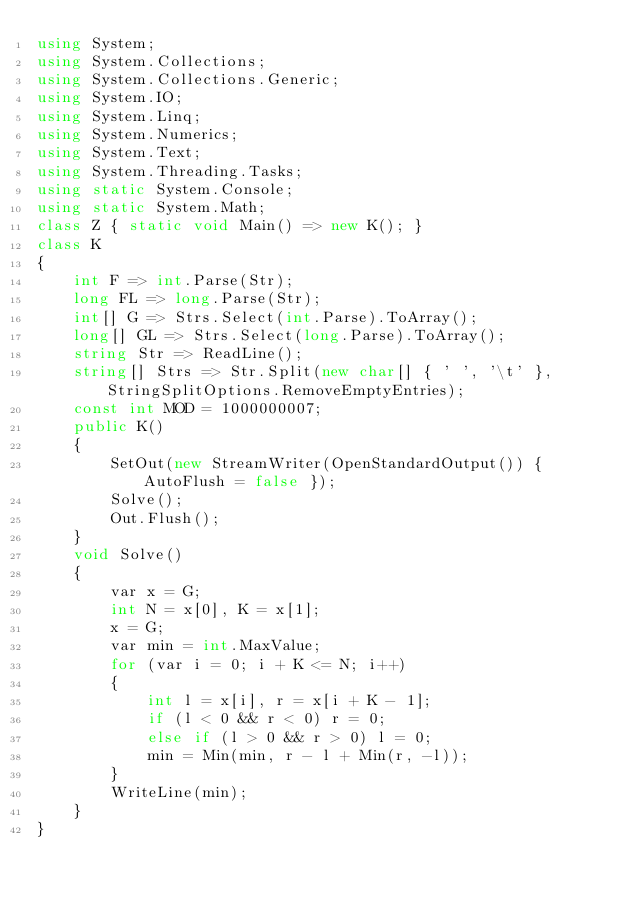Convert code to text. <code><loc_0><loc_0><loc_500><loc_500><_C#_>using System;
using System.Collections;
using System.Collections.Generic;
using System.IO;
using System.Linq;
using System.Numerics;
using System.Text;
using System.Threading.Tasks;
using static System.Console;
using static System.Math;
class Z { static void Main() => new K(); }
class K
{
	int F => int.Parse(Str);
	long FL => long.Parse(Str);
	int[] G => Strs.Select(int.Parse).ToArray();
	long[] GL => Strs.Select(long.Parse).ToArray();
	string Str => ReadLine();
	string[] Strs => Str.Split(new char[] { ' ', '\t' }, StringSplitOptions.RemoveEmptyEntries);
	const int MOD = 1000000007;
	public K()
	{
		SetOut(new StreamWriter(OpenStandardOutput()) { AutoFlush = false });
		Solve();
		Out.Flush();
	}
	void Solve()
	{
		var x = G;
		int N = x[0], K = x[1];
		x = G;
		var min = int.MaxValue;
		for (var i = 0; i + K <= N; i++)
		{
			int l = x[i], r = x[i + K - 1];
			if (l < 0 && r < 0) r = 0;
			else if (l > 0 && r > 0) l = 0;
			min = Min(min, r - l + Min(r, -l));
		}
		WriteLine(min);
	}
}
</code> 